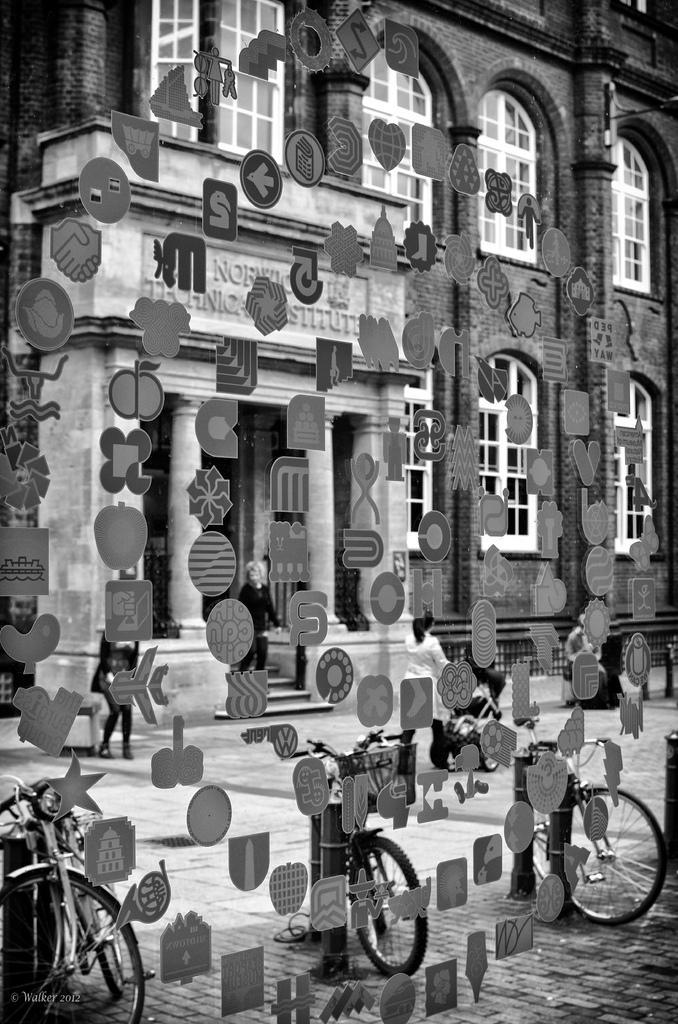Please provide a concise description of this image. This is a black and white image. These are the stickers, which are attached to the glass. I can see three bicycles, which are parked. This is the building with windows and pillars. Here is the woman holding a stroller and walking on the road. I can see few people standing. 